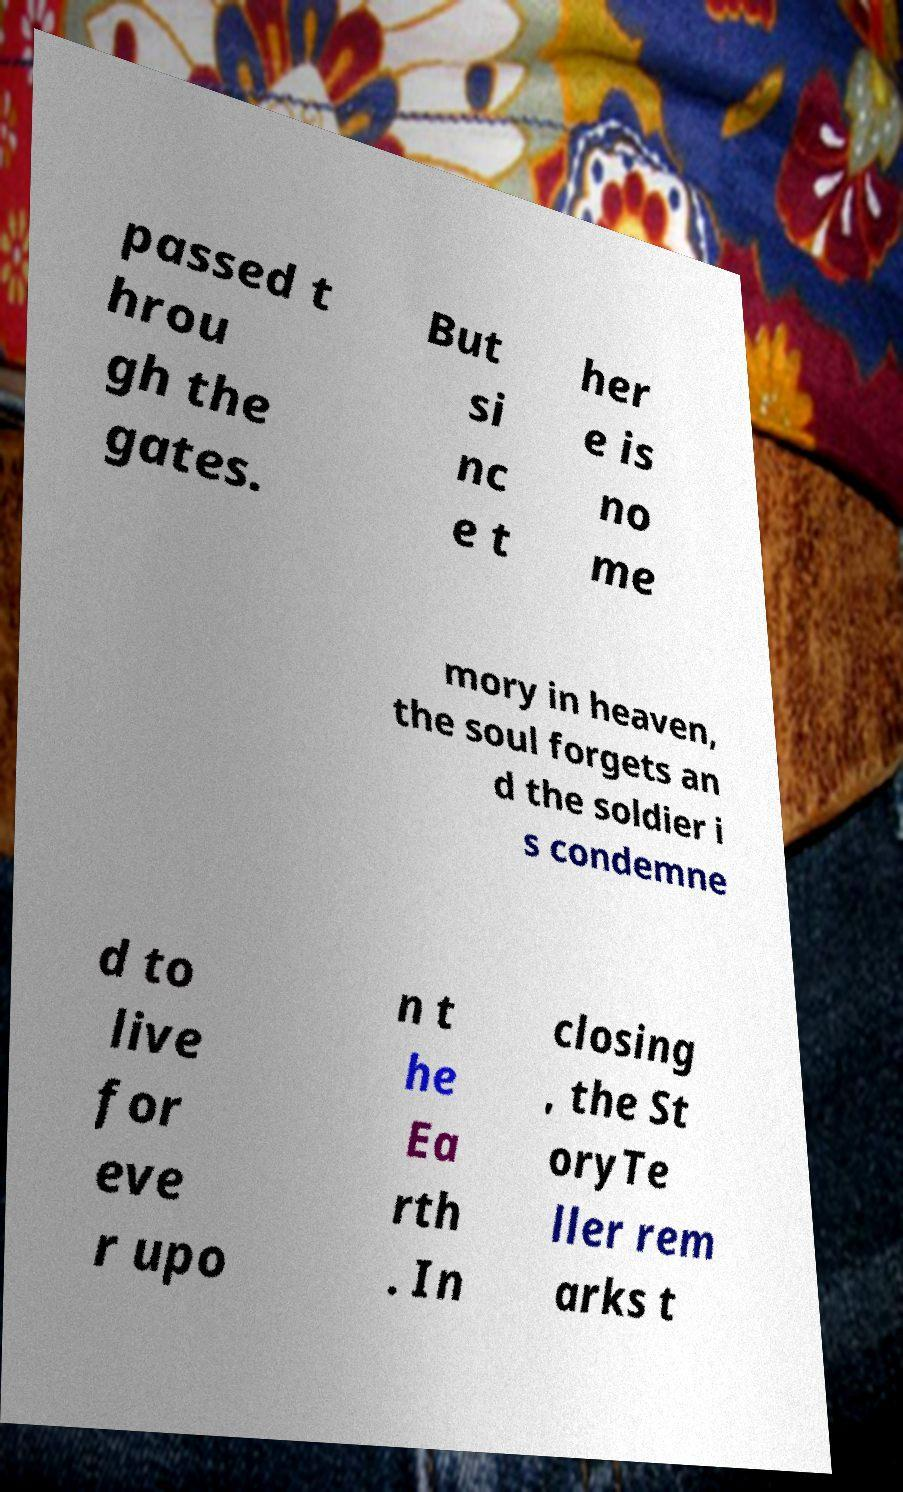What messages or text are displayed in this image? I need them in a readable, typed format. passed t hrou gh the gates. But si nc e t her e is no me mory in heaven, the soul forgets an d the soldier i s condemne d to live for eve r upo n t he Ea rth . In closing , the St oryTe ller rem arks t 